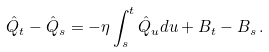Convert formula to latex. <formula><loc_0><loc_0><loc_500><loc_500>\hat { Q } _ { t } - \hat { Q } _ { s } = - \eta \int _ { s } ^ { t } \hat { Q } _ { u } d u + B _ { t } - B _ { s } \, .</formula> 